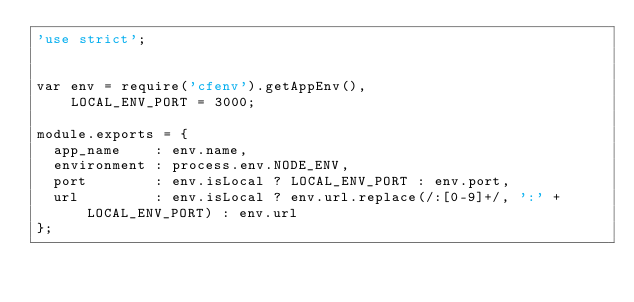<code> <loc_0><loc_0><loc_500><loc_500><_JavaScript_>'use strict';


var env = require('cfenv').getAppEnv(),
    LOCAL_ENV_PORT = 3000;

module.exports = {
  app_name    : env.name,
  environment : process.env.NODE_ENV,
  port        : env.isLocal ? LOCAL_ENV_PORT : env.port,
  url         : env.isLocal ? env.url.replace(/:[0-9]+/, ':' + LOCAL_ENV_PORT) : env.url
};
</code> 